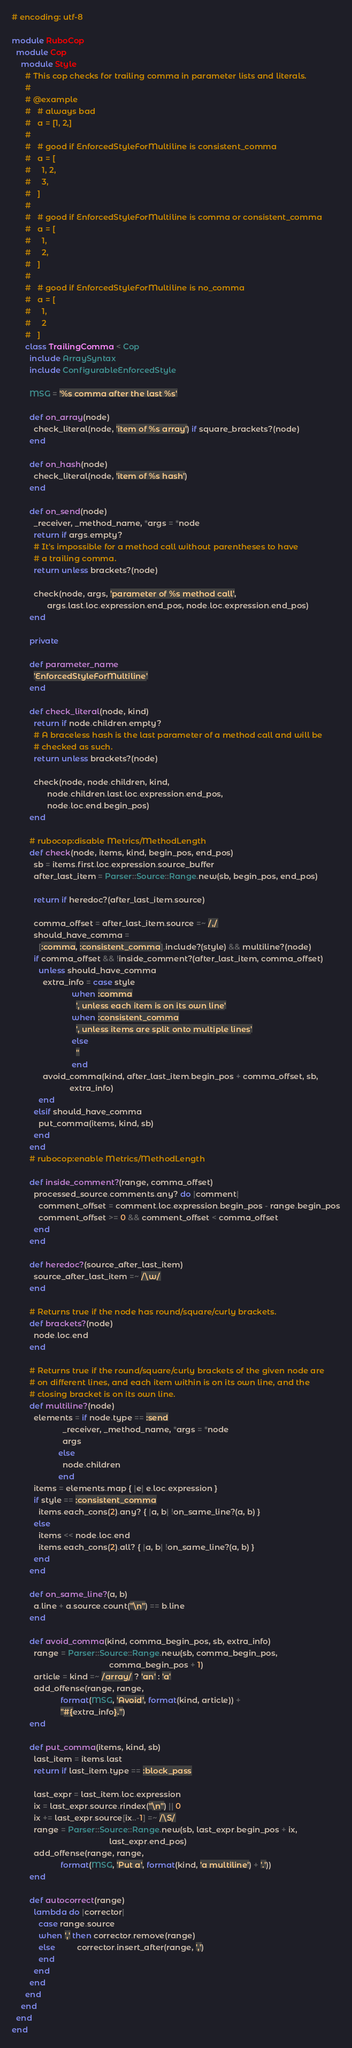<code> <loc_0><loc_0><loc_500><loc_500><_Ruby_># encoding: utf-8

module RuboCop
  module Cop
    module Style
      # This cop checks for trailing comma in parameter lists and literals.
      #
      # @example
      #   # always bad
      #   a = [1, 2,]
      #
      #   # good if EnforcedStyleForMultiline is consistent_comma
      #   a = [
      #     1, 2,
      #     3,
      #   ]
      #
      #   # good if EnforcedStyleForMultiline is comma or consistent_comma
      #   a = [
      #     1,
      #     2,
      #   ]
      #
      #   # good if EnforcedStyleForMultiline is no_comma
      #   a = [
      #     1,
      #     2
      #   ]
      class TrailingComma < Cop
        include ArraySyntax
        include ConfigurableEnforcedStyle

        MSG = '%s comma after the last %s'

        def on_array(node)
          check_literal(node, 'item of %s array') if square_brackets?(node)
        end

        def on_hash(node)
          check_literal(node, 'item of %s hash')
        end

        def on_send(node)
          _receiver, _method_name, *args = *node
          return if args.empty?
          # It's impossible for a method call without parentheses to have
          # a trailing comma.
          return unless brackets?(node)

          check(node, args, 'parameter of %s method call',
                args.last.loc.expression.end_pos, node.loc.expression.end_pos)
        end

        private

        def parameter_name
          'EnforcedStyleForMultiline'
        end

        def check_literal(node, kind)
          return if node.children.empty?
          # A braceless hash is the last parameter of a method call and will be
          # checked as such.
          return unless brackets?(node)

          check(node, node.children, kind,
                node.children.last.loc.expression.end_pos,
                node.loc.end.begin_pos)
        end

        # rubocop:disable Metrics/MethodLength
        def check(node, items, kind, begin_pos, end_pos)
          sb = items.first.loc.expression.source_buffer
          after_last_item = Parser::Source::Range.new(sb, begin_pos, end_pos)

          return if heredoc?(after_last_item.source)

          comma_offset = after_last_item.source =~ /,/
          should_have_comma =
            [:comma, :consistent_comma].include?(style) && multiline?(node)
          if comma_offset && !inside_comment?(after_last_item, comma_offset)
            unless should_have_comma
              extra_info = case style
                           when :comma
                             ', unless each item is on its own line'
                           when :consistent_comma
                             ', unless items are split onto multiple lines'
                           else
                             ''
                           end
              avoid_comma(kind, after_last_item.begin_pos + comma_offset, sb,
                          extra_info)
            end
          elsif should_have_comma
            put_comma(items, kind, sb)
          end
        end
        # rubocop:enable Metrics/MethodLength

        def inside_comment?(range, comma_offset)
          processed_source.comments.any? do |comment|
            comment_offset = comment.loc.expression.begin_pos - range.begin_pos
            comment_offset >= 0 && comment_offset < comma_offset
          end
        end

        def heredoc?(source_after_last_item)
          source_after_last_item =~ /\w/
        end

        # Returns true if the node has round/square/curly brackets.
        def brackets?(node)
          node.loc.end
        end

        # Returns true if the round/square/curly brackets of the given node are
        # on different lines, and each item within is on its own line, and the
        # closing bracket is on its own line.
        def multiline?(node)
          elements = if node.type == :send
                       _receiver, _method_name, *args = *node
                       args
                     else
                       node.children
                     end
          items = elements.map { |e| e.loc.expression }
          if style == :consistent_comma
            items.each_cons(2).any? { |a, b| !on_same_line?(a, b) }
          else
            items << node.loc.end
            items.each_cons(2).all? { |a, b| !on_same_line?(a, b) }
          end
        end

        def on_same_line?(a, b)
          a.line + a.source.count("\n") == b.line
        end

        def avoid_comma(kind, comma_begin_pos, sb, extra_info)
          range = Parser::Source::Range.new(sb, comma_begin_pos,
                                            comma_begin_pos + 1)
          article = kind =~ /array/ ? 'an' : 'a'
          add_offense(range, range,
                      format(MSG, 'Avoid', format(kind, article)) +
                      "#{extra_info}.")
        end

        def put_comma(items, kind, sb)
          last_item = items.last
          return if last_item.type == :block_pass

          last_expr = last_item.loc.expression
          ix = last_expr.source.rindex("\n") || 0
          ix += last_expr.source[ix..-1] =~ /\S/
          range = Parser::Source::Range.new(sb, last_expr.begin_pos + ix,
                                            last_expr.end_pos)
          add_offense(range, range,
                      format(MSG, 'Put a', format(kind, 'a multiline') + '.'))
        end

        def autocorrect(range)
          lambda do |corrector|
            case range.source
            when ',' then corrector.remove(range)
            else          corrector.insert_after(range, ',')
            end
          end
        end
      end
    end
  end
end
</code> 